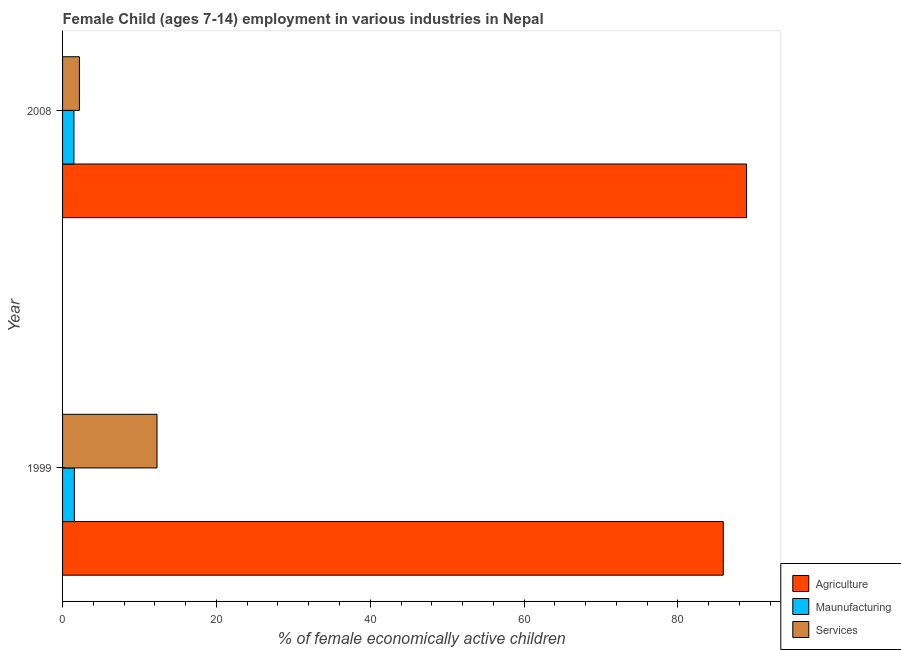How many different coloured bars are there?
Your response must be concise. 3. How many groups of bars are there?
Offer a terse response. 2. Are the number of bars on each tick of the Y-axis equal?
Give a very brief answer. Yes. How many bars are there on the 2nd tick from the top?
Keep it short and to the point. 3. What is the percentage of economically active children in agriculture in 1999?
Make the answer very short. 85.9. Across all years, what is the maximum percentage of economically active children in services?
Your answer should be compact. 12.28. Across all years, what is the minimum percentage of economically active children in manufacturing?
Offer a very short reply. 1.48. In which year was the percentage of economically active children in manufacturing minimum?
Your response must be concise. 2008. What is the total percentage of economically active children in manufacturing in the graph?
Offer a very short reply. 3.01. What is the difference between the percentage of economically active children in manufacturing in 1999 and that in 2008?
Offer a terse response. 0.05. What is the difference between the percentage of economically active children in agriculture in 2008 and the percentage of economically active children in services in 1999?
Provide a succinct answer. 76.65. What is the average percentage of economically active children in agriculture per year?
Keep it short and to the point. 87.42. In the year 2008, what is the difference between the percentage of economically active children in agriculture and percentage of economically active children in services?
Your answer should be very brief. 86.74. In how many years, is the percentage of economically active children in agriculture greater than 68 %?
Keep it short and to the point. 2. What is the ratio of the percentage of economically active children in manufacturing in 1999 to that in 2008?
Provide a short and direct response. 1.03. What does the 3rd bar from the top in 1999 represents?
Your answer should be very brief. Agriculture. What does the 2nd bar from the bottom in 1999 represents?
Give a very brief answer. Maunufacturing. Is it the case that in every year, the sum of the percentage of economically active children in agriculture and percentage of economically active children in manufacturing is greater than the percentage of economically active children in services?
Ensure brevity in your answer.  Yes. How many bars are there?
Your answer should be very brief. 6. Are all the bars in the graph horizontal?
Your response must be concise. Yes. How many years are there in the graph?
Offer a very short reply. 2. Are the values on the major ticks of X-axis written in scientific E-notation?
Keep it short and to the point. No. What is the title of the graph?
Give a very brief answer. Female Child (ages 7-14) employment in various industries in Nepal. What is the label or title of the X-axis?
Give a very brief answer. % of female economically active children. What is the label or title of the Y-axis?
Keep it short and to the point. Year. What is the % of female economically active children of Agriculture in 1999?
Offer a terse response. 85.9. What is the % of female economically active children in Maunufacturing in 1999?
Make the answer very short. 1.53. What is the % of female economically active children of Services in 1999?
Provide a succinct answer. 12.28. What is the % of female economically active children of Agriculture in 2008?
Your answer should be very brief. 88.93. What is the % of female economically active children in Maunufacturing in 2008?
Give a very brief answer. 1.48. What is the % of female economically active children in Services in 2008?
Offer a very short reply. 2.19. Across all years, what is the maximum % of female economically active children in Agriculture?
Ensure brevity in your answer.  88.93. Across all years, what is the maximum % of female economically active children in Maunufacturing?
Give a very brief answer. 1.53. Across all years, what is the maximum % of female economically active children in Services?
Your answer should be compact. 12.28. Across all years, what is the minimum % of female economically active children in Agriculture?
Offer a terse response. 85.9. Across all years, what is the minimum % of female economically active children in Maunufacturing?
Give a very brief answer. 1.48. Across all years, what is the minimum % of female economically active children in Services?
Offer a very short reply. 2.19. What is the total % of female economically active children in Agriculture in the graph?
Keep it short and to the point. 174.83. What is the total % of female economically active children of Maunufacturing in the graph?
Give a very brief answer. 3.01. What is the total % of female economically active children in Services in the graph?
Offer a very short reply. 14.47. What is the difference between the % of female economically active children in Agriculture in 1999 and that in 2008?
Provide a short and direct response. -3.03. What is the difference between the % of female economically active children in Maunufacturing in 1999 and that in 2008?
Provide a succinct answer. 0.05. What is the difference between the % of female economically active children of Services in 1999 and that in 2008?
Keep it short and to the point. 10.09. What is the difference between the % of female economically active children of Agriculture in 1999 and the % of female economically active children of Maunufacturing in 2008?
Keep it short and to the point. 84.42. What is the difference between the % of female economically active children of Agriculture in 1999 and the % of female economically active children of Services in 2008?
Ensure brevity in your answer.  83.71. What is the difference between the % of female economically active children in Maunufacturing in 1999 and the % of female economically active children in Services in 2008?
Your response must be concise. -0.66. What is the average % of female economically active children in Agriculture per year?
Make the answer very short. 87.42. What is the average % of female economically active children of Maunufacturing per year?
Offer a terse response. 1.51. What is the average % of female economically active children of Services per year?
Your answer should be compact. 7.24. In the year 1999, what is the difference between the % of female economically active children in Agriculture and % of female economically active children in Maunufacturing?
Ensure brevity in your answer.  84.37. In the year 1999, what is the difference between the % of female economically active children in Agriculture and % of female economically active children in Services?
Ensure brevity in your answer.  73.62. In the year 1999, what is the difference between the % of female economically active children in Maunufacturing and % of female economically active children in Services?
Offer a terse response. -10.75. In the year 2008, what is the difference between the % of female economically active children of Agriculture and % of female economically active children of Maunufacturing?
Keep it short and to the point. 87.45. In the year 2008, what is the difference between the % of female economically active children in Agriculture and % of female economically active children in Services?
Ensure brevity in your answer.  86.74. In the year 2008, what is the difference between the % of female economically active children in Maunufacturing and % of female economically active children in Services?
Ensure brevity in your answer.  -0.71. What is the ratio of the % of female economically active children in Agriculture in 1999 to that in 2008?
Provide a succinct answer. 0.97. What is the ratio of the % of female economically active children in Maunufacturing in 1999 to that in 2008?
Provide a succinct answer. 1.03. What is the ratio of the % of female economically active children in Services in 1999 to that in 2008?
Keep it short and to the point. 5.61. What is the difference between the highest and the second highest % of female economically active children in Agriculture?
Make the answer very short. 3.03. What is the difference between the highest and the second highest % of female economically active children of Maunufacturing?
Provide a succinct answer. 0.05. What is the difference between the highest and the second highest % of female economically active children of Services?
Provide a succinct answer. 10.09. What is the difference between the highest and the lowest % of female economically active children of Agriculture?
Your answer should be very brief. 3.03. What is the difference between the highest and the lowest % of female economically active children of Maunufacturing?
Offer a very short reply. 0.05. What is the difference between the highest and the lowest % of female economically active children in Services?
Make the answer very short. 10.09. 